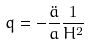Convert formula to latex. <formula><loc_0><loc_0><loc_500><loc_500>q = - \frac { \ddot { a } } { a } \frac { 1 } { H ^ { 2 } }</formula> 